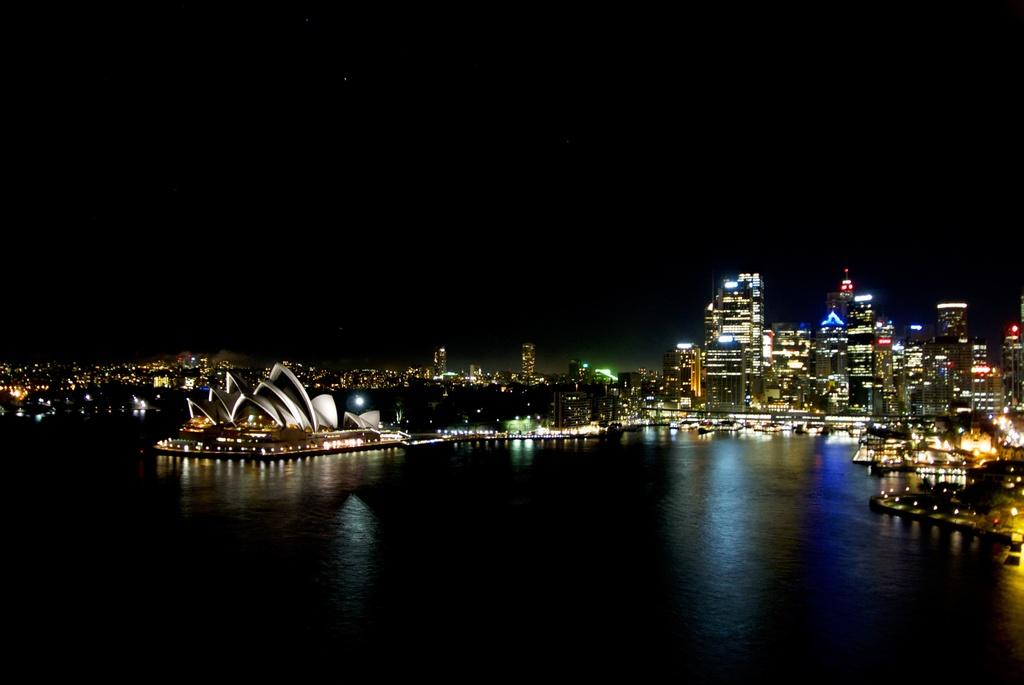What is the primary element visible in the image? There is a water surface in the image. What can be seen in the distance behind the water surface? There is an architecture and buildings in the background of the image. Are there any illuminated elements in the background? Yes, there are lights visible in the background of the image. What type of insurance policy is being discussed in the image? There is no mention of insurance or any discussion in the image; it primarily features a water surface and background elements. 